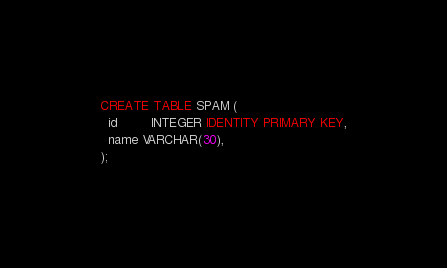Convert code to text. <code><loc_0><loc_0><loc_500><loc_500><_SQL_>CREATE TABLE SPAM (
  id         INTEGER IDENTITY PRIMARY KEY,
  name VARCHAR(30),
);
</code> 